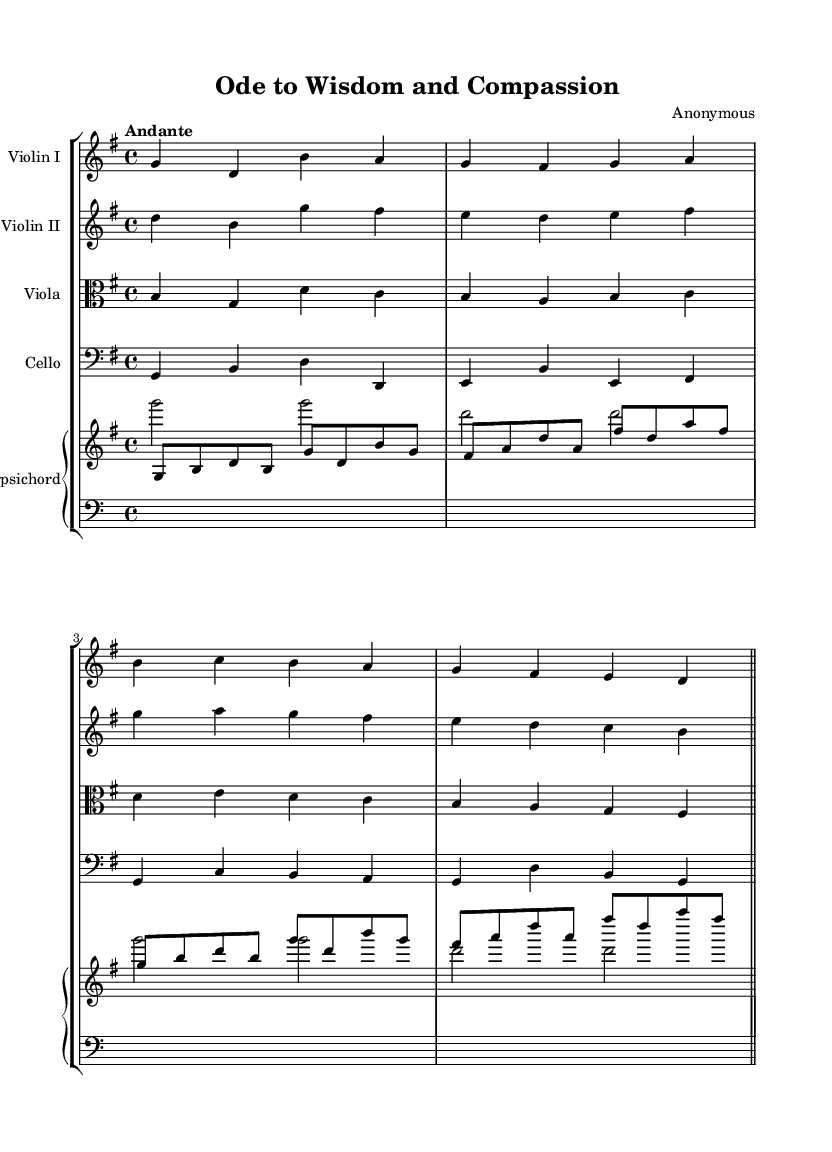What is the key signature of this music? The key signature is G major, which has one sharp (F#). This can be determined by looking at the beginning of the staff where the key signature is notated.
Answer: G major What is the time signature of this piece? The time signature is 4/4, indicated at the start of the piece. This means there are four beats in a measure, and the quarter note gets the beat.
Answer: 4/4 What is the tempo marking given in this composition? The tempo marking is "Andante," which indicates a moderate pace. This can be found noted prominently at the beginning of the score next to the time signature.
Answer: Andante How many instruments are featured in this score? There are five instruments featured in the score: two violins, a viola, a cello, and a harpsichord. This can be seen from the number of staff lines in the score, each indicating a different instrument.
Answer: Five What is the overall structure indicated by the ending bar line in the music? The piece ends with a double bar line, indicating the conclusion of the composition. This is visually represented by the two vertical lines at the end of the last measure.
Answer: Double bar line Which instrument has the highest pitch in this composition? The violin I part typically plays in the higher register compared to the other instruments. By observing the notation and the range of notes, it is clear that the violin I has the highest pitch.
Answer: Violin I What are the clefs used in the viola and cello parts? The viola part uses the alto clef while the cello part uses the bass clef. This is indicated at the beginning of each respective staff, denoting the range of notes for those instruments.
Answer: Alto clef and bass clef 